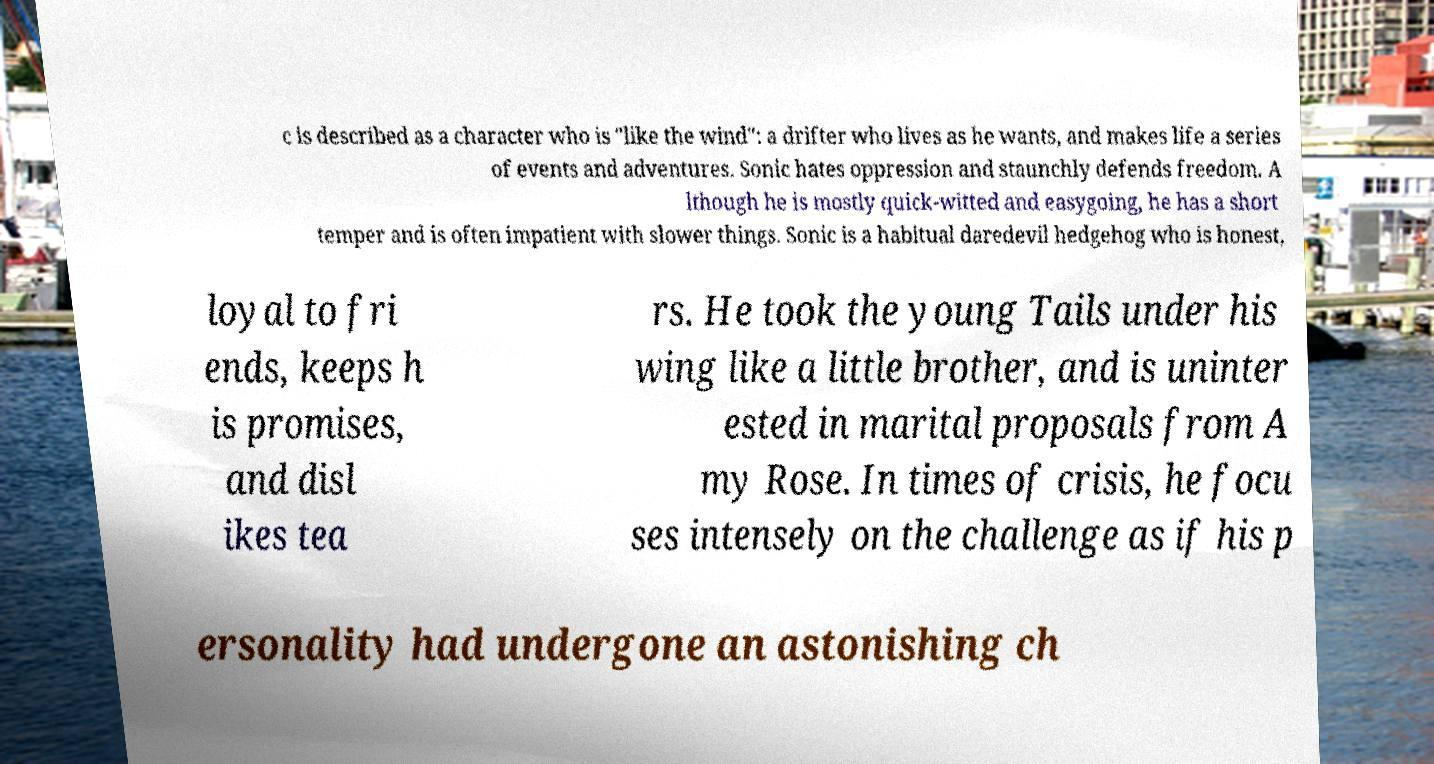Could you assist in decoding the text presented in this image and type it out clearly? c is described as a character who is "like the wind": a drifter who lives as he wants, and makes life a series of events and adventures. Sonic hates oppression and staunchly defends freedom. A lthough he is mostly quick-witted and easygoing, he has a short temper and is often impatient with slower things. Sonic is a habitual daredevil hedgehog who is honest, loyal to fri ends, keeps h is promises, and disl ikes tea rs. He took the young Tails under his wing like a little brother, and is uninter ested in marital proposals from A my Rose. In times of crisis, he focu ses intensely on the challenge as if his p ersonality had undergone an astonishing ch 